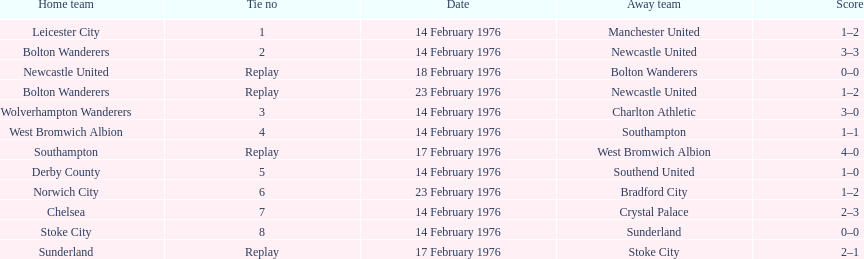How many games were replays? 4. 